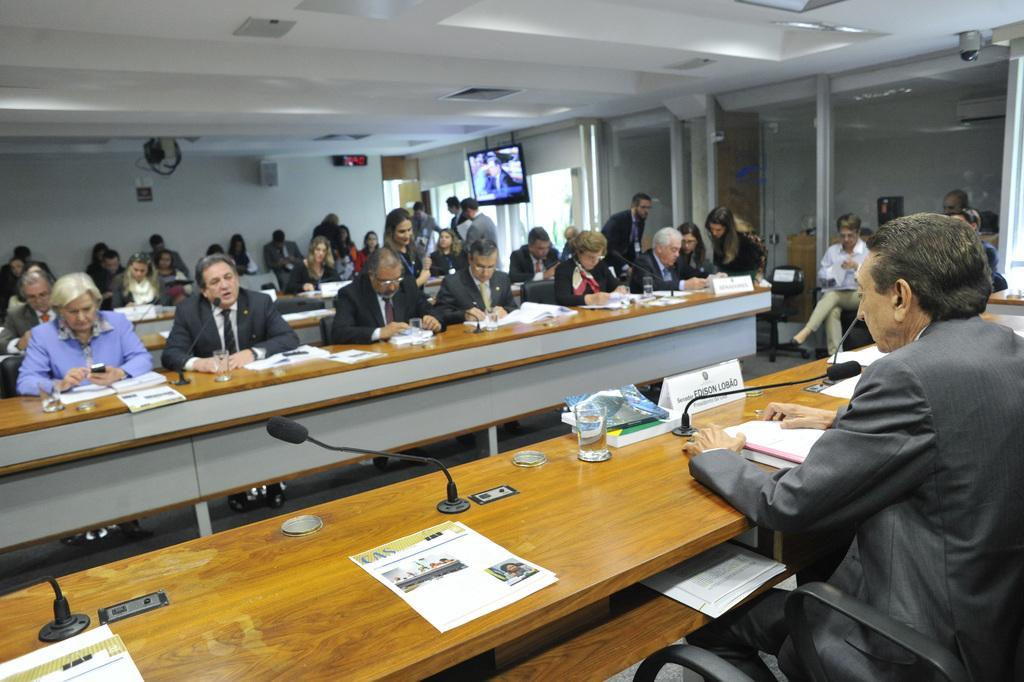Describe this image in one or two sentences. In this image there are people sitting on chairs, in the middle there are tables, on that tables there are mike's, papers, and glasses, in the background there is a wall, at the top there is a ceiling and a monitor. 